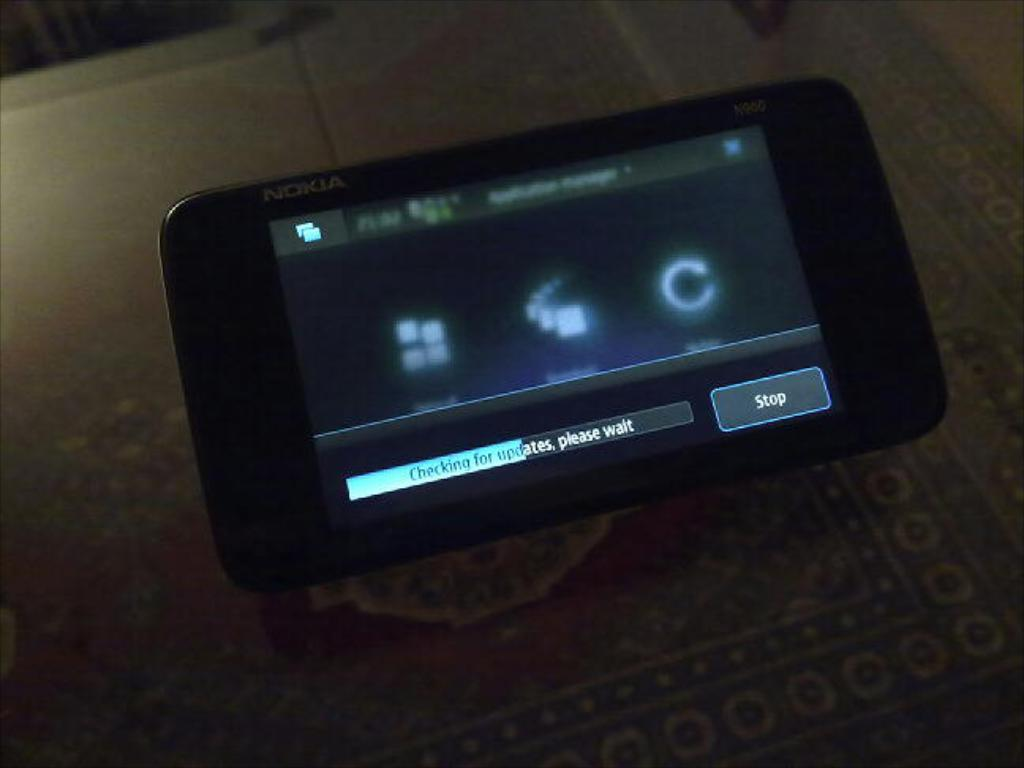<image>
Summarize the visual content of the image. a cell phone by NOKIA showing a screen Checking for Updates 